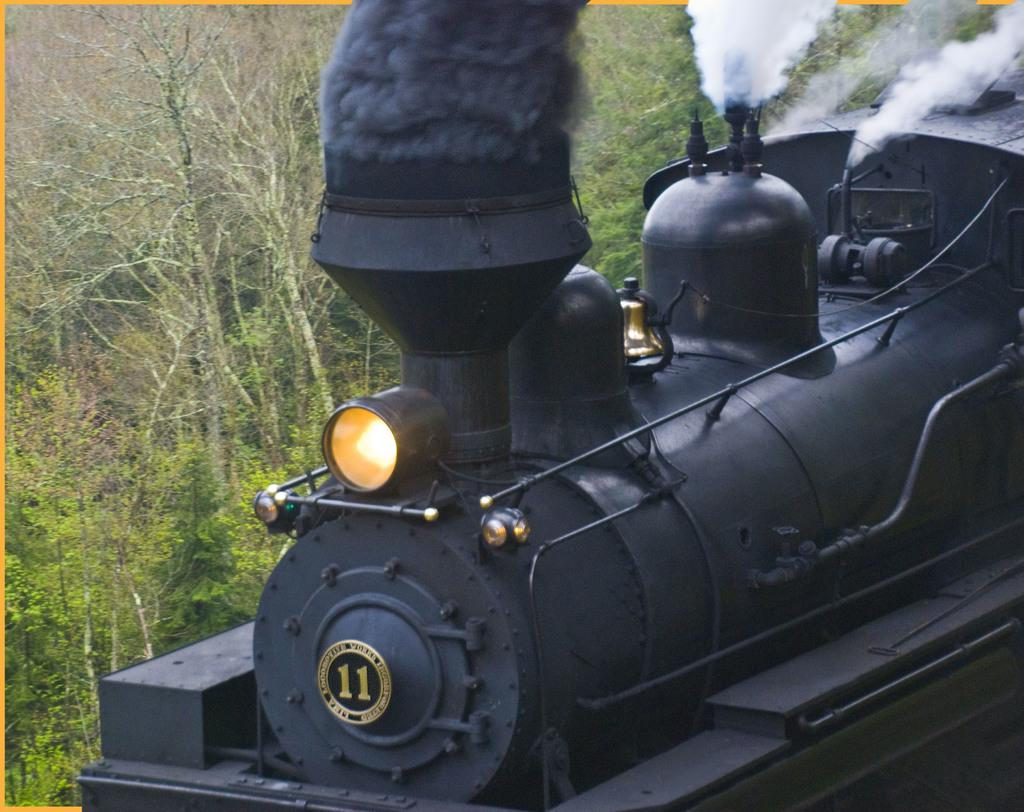<image>
Summarize the visual content of the image. The Lima Locomotive Works number 11 is blowing smoke from its stack. 